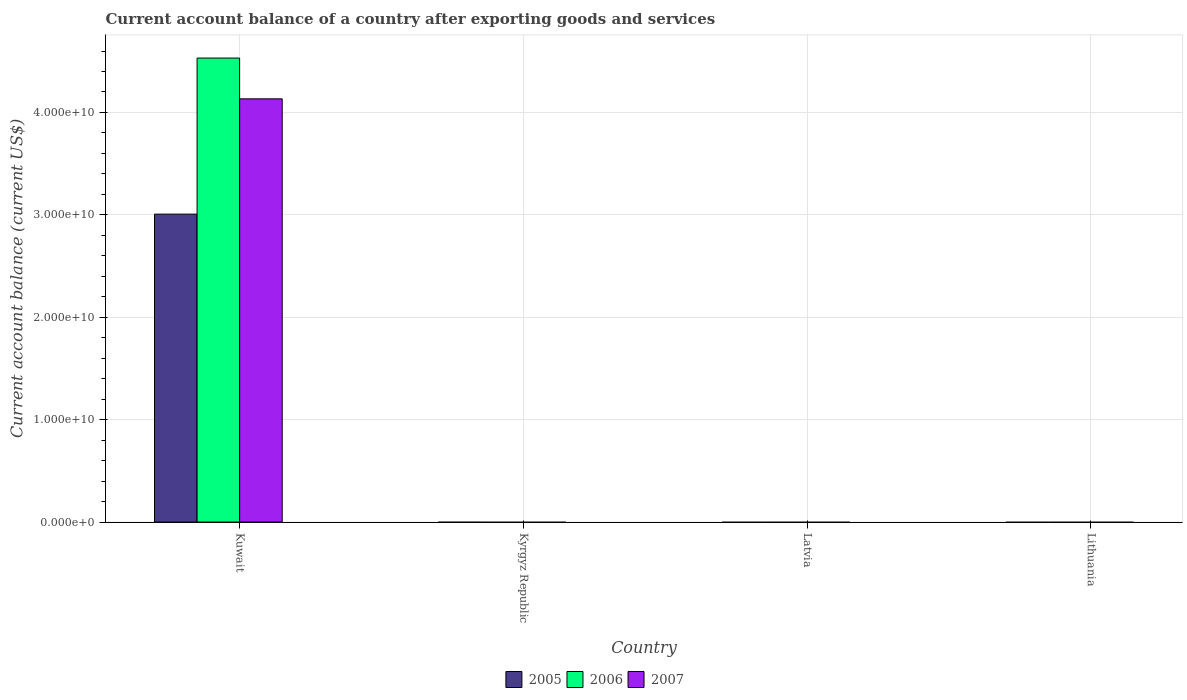Are the number of bars per tick equal to the number of legend labels?
Provide a short and direct response. No. Are the number of bars on each tick of the X-axis equal?
Offer a terse response. No. How many bars are there on the 4th tick from the right?
Provide a succinct answer. 3. What is the label of the 2nd group of bars from the left?
Your answer should be compact. Kyrgyz Republic. In how many cases, is the number of bars for a given country not equal to the number of legend labels?
Keep it short and to the point. 3. What is the account balance in 2006 in Lithuania?
Offer a terse response. 0. Across all countries, what is the maximum account balance in 2006?
Provide a succinct answer. 4.53e+1. In which country was the account balance in 2005 maximum?
Offer a very short reply. Kuwait. What is the total account balance in 2005 in the graph?
Ensure brevity in your answer.  3.01e+1. What is the difference between the account balance in 2007 in Kuwait and the account balance in 2005 in Latvia?
Provide a short and direct response. 4.13e+1. What is the average account balance in 2005 per country?
Provide a short and direct response. 7.52e+09. What is the difference between the account balance of/in 2006 and account balance of/in 2007 in Kuwait?
Make the answer very short. 3.98e+09. What is the difference between the highest and the lowest account balance in 2005?
Offer a very short reply. 3.01e+1. In how many countries, is the account balance in 2005 greater than the average account balance in 2005 taken over all countries?
Offer a very short reply. 1. Is it the case that in every country, the sum of the account balance in 2006 and account balance in 2007 is greater than the account balance in 2005?
Provide a succinct answer. No. How many bars are there?
Ensure brevity in your answer.  3. How many countries are there in the graph?
Ensure brevity in your answer.  4. What is the difference between two consecutive major ticks on the Y-axis?
Ensure brevity in your answer.  1.00e+1. Are the values on the major ticks of Y-axis written in scientific E-notation?
Ensure brevity in your answer.  Yes. Does the graph contain grids?
Offer a very short reply. Yes. Where does the legend appear in the graph?
Your answer should be very brief. Bottom center. How many legend labels are there?
Give a very brief answer. 3. How are the legend labels stacked?
Your response must be concise. Horizontal. What is the title of the graph?
Offer a terse response. Current account balance of a country after exporting goods and services. What is the label or title of the Y-axis?
Give a very brief answer. Current account balance (current US$). What is the Current account balance (current US$) in 2005 in Kuwait?
Ensure brevity in your answer.  3.01e+1. What is the Current account balance (current US$) in 2006 in Kuwait?
Your answer should be very brief. 4.53e+1. What is the Current account balance (current US$) of 2007 in Kuwait?
Your answer should be very brief. 4.13e+1. What is the Current account balance (current US$) of 2005 in Kyrgyz Republic?
Make the answer very short. 0. What is the Current account balance (current US$) of 2006 in Kyrgyz Republic?
Keep it short and to the point. 0. What is the Current account balance (current US$) of 2005 in Latvia?
Provide a short and direct response. 0. What is the Current account balance (current US$) of 2006 in Latvia?
Your answer should be very brief. 0. What is the Current account balance (current US$) in 2006 in Lithuania?
Make the answer very short. 0. Across all countries, what is the maximum Current account balance (current US$) in 2005?
Provide a short and direct response. 3.01e+1. Across all countries, what is the maximum Current account balance (current US$) of 2006?
Make the answer very short. 4.53e+1. Across all countries, what is the maximum Current account balance (current US$) in 2007?
Your answer should be very brief. 4.13e+1. Across all countries, what is the minimum Current account balance (current US$) of 2006?
Make the answer very short. 0. Across all countries, what is the minimum Current account balance (current US$) of 2007?
Provide a succinct answer. 0. What is the total Current account balance (current US$) of 2005 in the graph?
Your response must be concise. 3.01e+1. What is the total Current account balance (current US$) in 2006 in the graph?
Offer a terse response. 4.53e+1. What is the total Current account balance (current US$) in 2007 in the graph?
Your answer should be very brief. 4.13e+1. What is the average Current account balance (current US$) in 2005 per country?
Offer a very short reply. 7.52e+09. What is the average Current account balance (current US$) of 2006 per country?
Keep it short and to the point. 1.13e+1. What is the average Current account balance (current US$) of 2007 per country?
Your response must be concise. 1.03e+1. What is the difference between the Current account balance (current US$) in 2005 and Current account balance (current US$) in 2006 in Kuwait?
Your answer should be very brief. -1.52e+1. What is the difference between the Current account balance (current US$) in 2005 and Current account balance (current US$) in 2007 in Kuwait?
Offer a terse response. -1.13e+1. What is the difference between the Current account balance (current US$) in 2006 and Current account balance (current US$) in 2007 in Kuwait?
Provide a succinct answer. 3.98e+09. What is the difference between the highest and the lowest Current account balance (current US$) of 2005?
Offer a terse response. 3.01e+1. What is the difference between the highest and the lowest Current account balance (current US$) of 2006?
Make the answer very short. 4.53e+1. What is the difference between the highest and the lowest Current account balance (current US$) in 2007?
Your answer should be compact. 4.13e+1. 